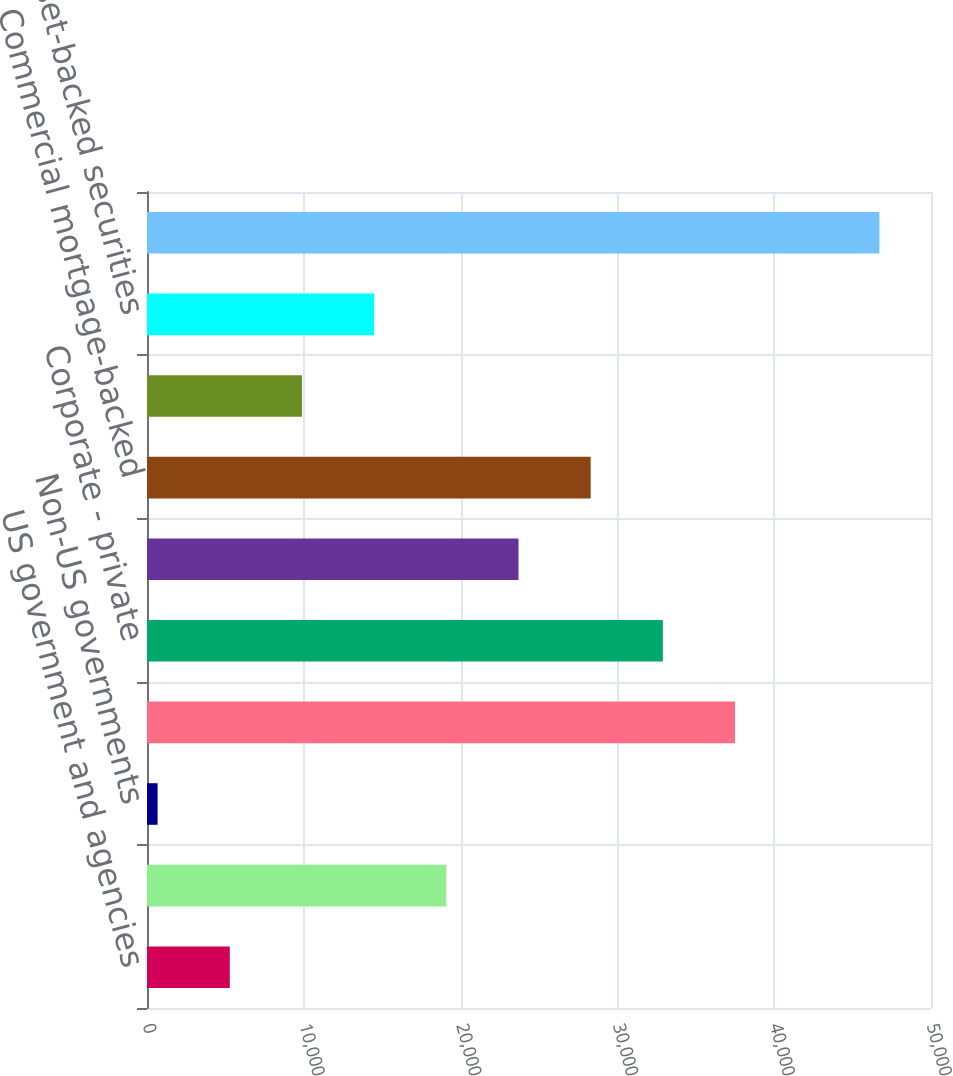Convert chart to OTSL. <chart><loc_0><loc_0><loc_500><loc_500><bar_chart><fcel>US government and agencies<fcel>States and political<fcel>Non-US governments<fcel>Corporate - public<fcel>Corporate - private<fcel>Residential mortgage-backed<fcel>Commercial mortgage-backed<fcel>Residential collateralized<fcel>Asset-backed securities<fcel>Total fixed maturities<nl><fcel>5279.42<fcel>19089.4<fcel>676.1<fcel>37502.7<fcel>32899.3<fcel>23692.7<fcel>28296<fcel>9882.74<fcel>14486.1<fcel>46709.3<nl></chart> 